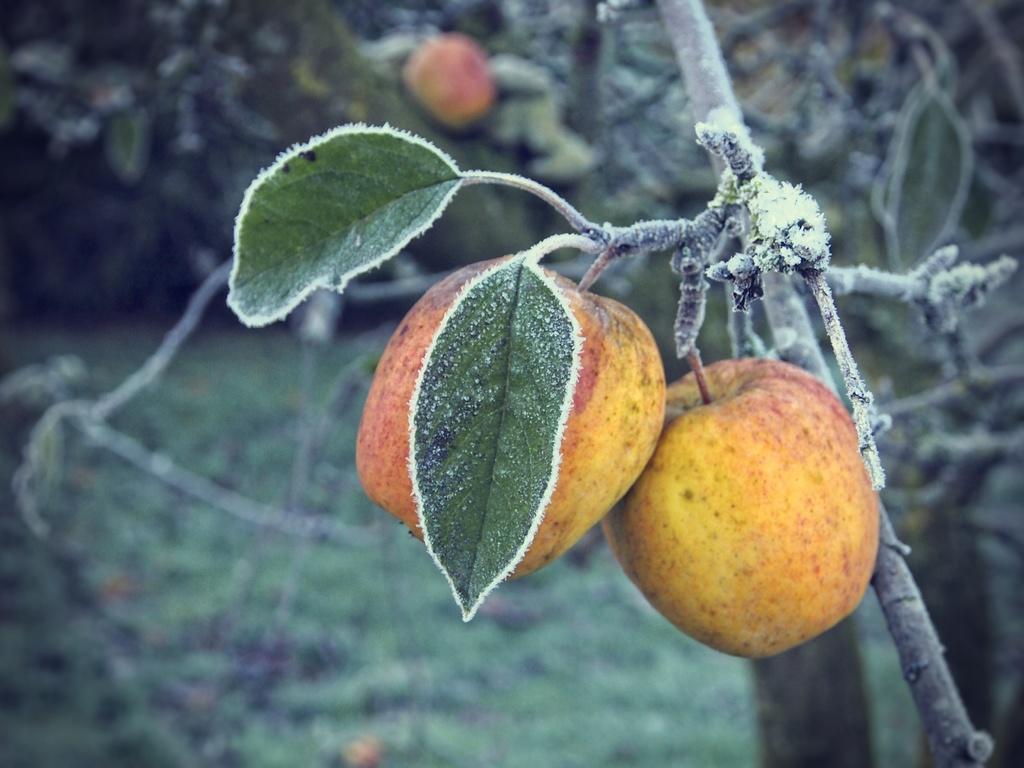How would you summarize this image in a sentence or two? In this picture, we can see fruits, leaves of a tree are highlighted, and we can see the blurred background. 